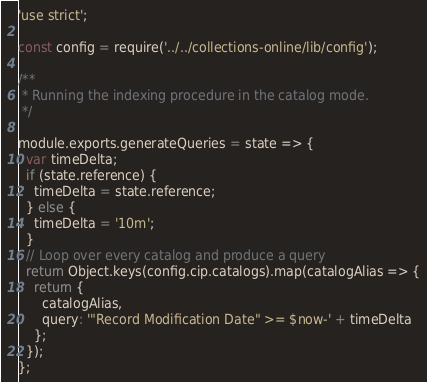<code> <loc_0><loc_0><loc_500><loc_500><_JavaScript_>'use strict';

const config = require('../../collections-online/lib/config');

/**
 * Running the indexing procedure in the catalog mode.
 */

module.exports.generateQueries = state => {
  var timeDelta;
  if (state.reference) {
    timeDelta = state.reference;
  } else {
    timeDelta = '10m';
  }
  // Loop over every catalog and produce a query
  return Object.keys(config.cip.catalogs).map(catalogAlias => {
    return {
      catalogAlias,
      query: '"Record Modification Date" >= $now-' + timeDelta
    };
  });
};
</code> 